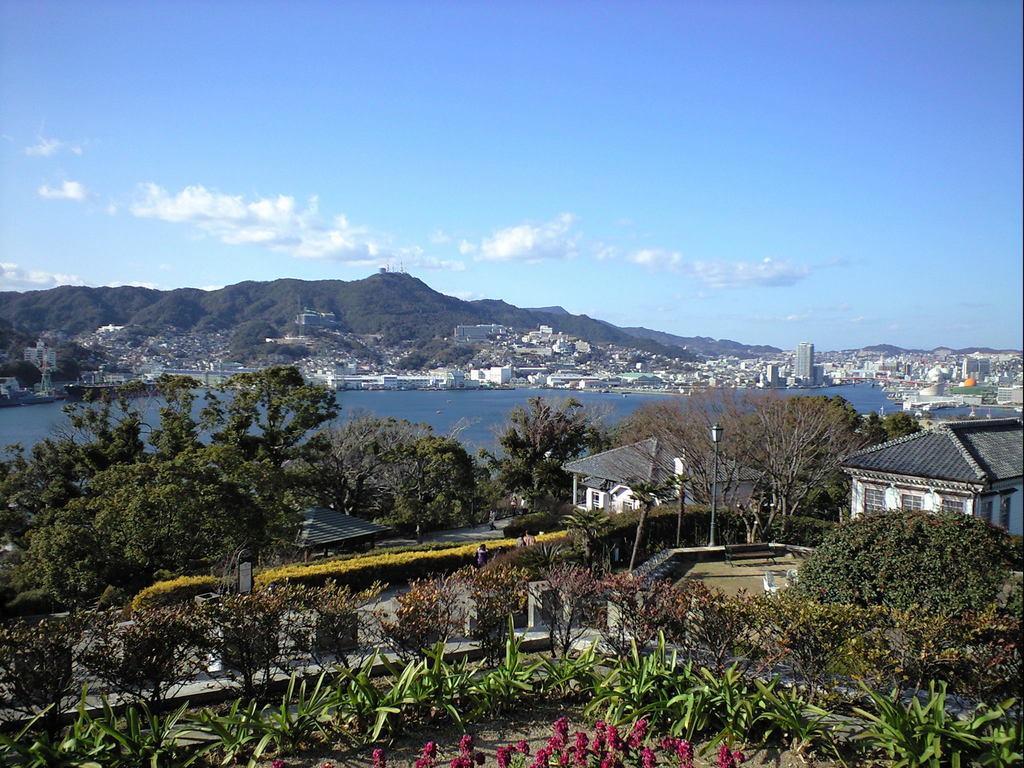Can you describe this image briefly? In the center of the image there are trees and we can see sheds. At the bottom there are plants. In the background there is water, buildings, hills and sky. We can see people. 